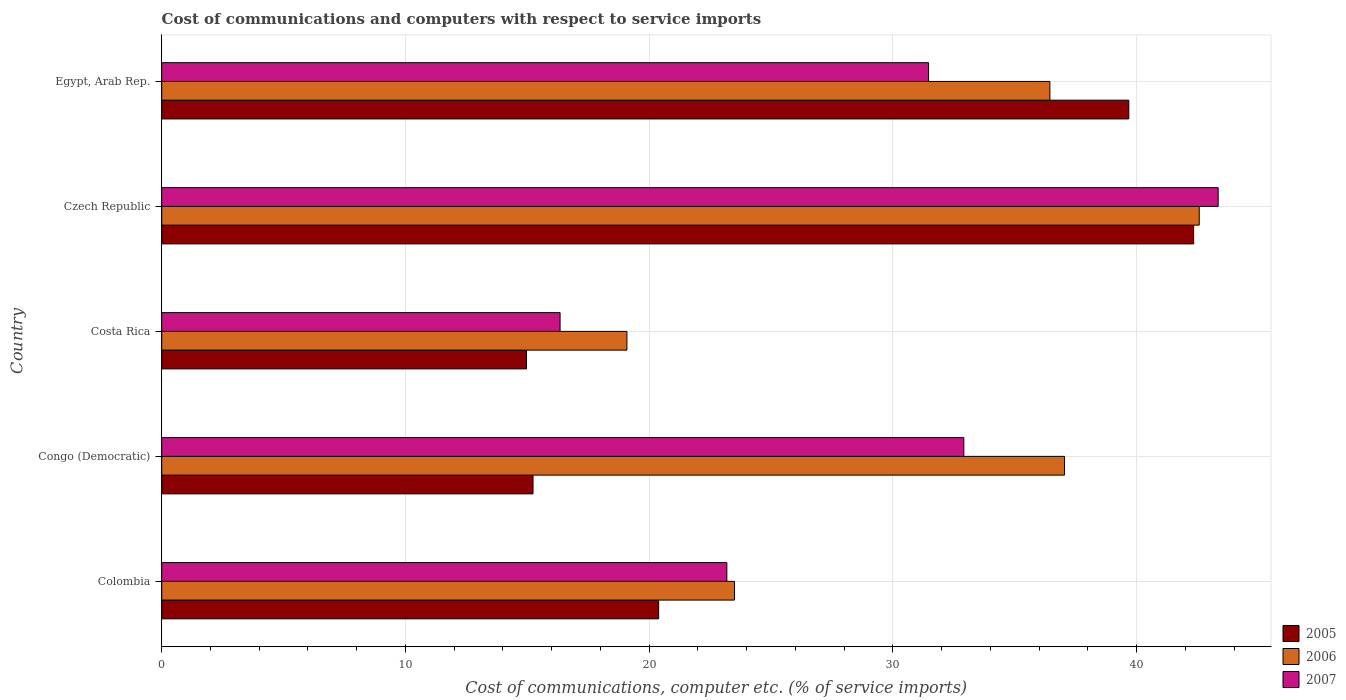How many different coloured bars are there?
Keep it short and to the point. 3. How many groups of bars are there?
Give a very brief answer. 5. How many bars are there on the 5th tick from the top?
Give a very brief answer. 3. What is the label of the 3rd group of bars from the top?
Your answer should be very brief. Costa Rica. What is the cost of communications and computers in 2005 in Congo (Democratic)?
Offer a terse response. 15.23. Across all countries, what is the maximum cost of communications and computers in 2007?
Keep it short and to the point. 43.34. Across all countries, what is the minimum cost of communications and computers in 2006?
Make the answer very short. 19.09. In which country was the cost of communications and computers in 2007 maximum?
Your answer should be compact. Czech Republic. What is the total cost of communications and computers in 2007 in the graph?
Ensure brevity in your answer.  147.24. What is the difference between the cost of communications and computers in 2006 in Costa Rica and that in Czech Republic?
Keep it short and to the point. -23.48. What is the difference between the cost of communications and computers in 2006 in Czech Republic and the cost of communications and computers in 2007 in Colombia?
Your answer should be very brief. 19.38. What is the average cost of communications and computers in 2005 per country?
Provide a succinct answer. 26.52. What is the difference between the cost of communications and computers in 2005 and cost of communications and computers in 2006 in Czech Republic?
Your answer should be compact. -0.23. In how many countries, is the cost of communications and computers in 2005 greater than 34 %?
Your response must be concise. 2. What is the ratio of the cost of communications and computers in 2006 in Costa Rica to that in Egypt, Arab Rep.?
Give a very brief answer. 0.52. Is the cost of communications and computers in 2006 in Congo (Democratic) less than that in Egypt, Arab Rep.?
Ensure brevity in your answer.  No. Is the difference between the cost of communications and computers in 2005 in Czech Republic and Egypt, Arab Rep. greater than the difference between the cost of communications and computers in 2006 in Czech Republic and Egypt, Arab Rep.?
Keep it short and to the point. No. What is the difference between the highest and the second highest cost of communications and computers in 2006?
Your response must be concise. 5.53. What is the difference between the highest and the lowest cost of communications and computers in 2006?
Keep it short and to the point. 23.48. In how many countries, is the cost of communications and computers in 2007 greater than the average cost of communications and computers in 2007 taken over all countries?
Your answer should be compact. 3. Is the sum of the cost of communications and computers in 2005 in Czech Republic and Egypt, Arab Rep. greater than the maximum cost of communications and computers in 2007 across all countries?
Your answer should be compact. Yes. How many bars are there?
Provide a short and direct response. 15. Are all the bars in the graph horizontal?
Make the answer very short. Yes. Does the graph contain any zero values?
Offer a very short reply. No. Where does the legend appear in the graph?
Make the answer very short. Bottom right. What is the title of the graph?
Offer a terse response. Cost of communications and computers with respect to service imports. What is the label or title of the X-axis?
Offer a terse response. Cost of communications, computer etc. (% of service imports). What is the Cost of communications, computer etc. (% of service imports) of 2005 in Colombia?
Your answer should be very brief. 20.39. What is the Cost of communications, computer etc. (% of service imports) in 2006 in Colombia?
Keep it short and to the point. 23.5. What is the Cost of communications, computer etc. (% of service imports) in 2007 in Colombia?
Provide a succinct answer. 23.18. What is the Cost of communications, computer etc. (% of service imports) in 2005 in Congo (Democratic)?
Ensure brevity in your answer.  15.23. What is the Cost of communications, computer etc. (% of service imports) in 2006 in Congo (Democratic)?
Offer a very short reply. 37.04. What is the Cost of communications, computer etc. (% of service imports) of 2007 in Congo (Democratic)?
Offer a very short reply. 32.91. What is the Cost of communications, computer etc. (% of service imports) of 2005 in Costa Rica?
Your answer should be very brief. 14.97. What is the Cost of communications, computer etc. (% of service imports) of 2006 in Costa Rica?
Your answer should be very brief. 19.09. What is the Cost of communications, computer etc. (% of service imports) of 2007 in Costa Rica?
Your response must be concise. 16.34. What is the Cost of communications, computer etc. (% of service imports) of 2005 in Czech Republic?
Provide a short and direct response. 42.33. What is the Cost of communications, computer etc. (% of service imports) in 2006 in Czech Republic?
Ensure brevity in your answer.  42.56. What is the Cost of communications, computer etc. (% of service imports) in 2007 in Czech Republic?
Your answer should be very brief. 43.34. What is the Cost of communications, computer etc. (% of service imports) in 2005 in Egypt, Arab Rep.?
Provide a succinct answer. 39.68. What is the Cost of communications, computer etc. (% of service imports) in 2006 in Egypt, Arab Rep.?
Provide a short and direct response. 36.44. What is the Cost of communications, computer etc. (% of service imports) in 2007 in Egypt, Arab Rep.?
Make the answer very short. 31.46. Across all countries, what is the maximum Cost of communications, computer etc. (% of service imports) of 2005?
Your answer should be very brief. 42.33. Across all countries, what is the maximum Cost of communications, computer etc. (% of service imports) of 2006?
Your response must be concise. 42.56. Across all countries, what is the maximum Cost of communications, computer etc. (% of service imports) of 2007?
Offer a terse response. 43.34. Across all countries, what is the minimum Cost of communications, computer etc. (% of service imports) in 2005?
Your answer should be very brief. 14.97. Across all countries, what is the minimum Cost of communications, computer etc. (% of service imports) in 2006?
Give a very brief answer. 19.09. Across all countries, what is the minimum Cost of communications, computer etc. (% of service imports) in 2007?
Your answer should be very brief. 16.34. What is the total Cost of communications, computer etc. (% of service imports) of 2005 in the graph?
Give a very brief answer. 132.6. What is the total Cost of communications, computer etc. (% of service imports) of 2006 in the graph?
Keep it short and to the point. 158.63. What is the total Cost of communications, computer etc. (% of service imports) in 2007 in the graph?
Offer a terse response. 147.24. What is the difference between the Cost of communications, computer etc. (% of service imports) of 2005 in Colombia and that in Congo (Democratic)?
Your answer should be compact. 5.15. What is the difference between the Cost of communications, computer etc. (% of service imports) of 2006 in Colombia and that in Congo (Democratic)?
Make the answer very short. -13.54. What is the difference between the Cost of communications, computer etc. (% of service imports) of 2007 in Colombia and that in Congo (Democratic)?
Provide a short and direct response. -9.72. What is the difference between the Cost of communications, computer etc. (% of service imports) of 2005 in Colombia and that in Costa Rica?
Offer a terse response. 5.42. What is the difference between the Cost of communications, computer etc. (% of service imports) in 2006 in Colombia and that in Costa Rica?
Ensure brevity in your answer.  4.41. What is the difference between the Cost of communications, computer etc. (% of service imports) in 2007 in Colombia and that in Costa Rica?
Your answer should be very brief. 6.84. What is the difference between the Cost of communications, computer etc. (% of service imports) in 2005 in Colombia and that in Czech Republic?
Offer a terse response. -21.95. What is the difference between the Cost of communications, computer etc. (% of service imports) in 2006 in Colombia and that in Czech Republic?
Provide a short and direct response. -19.06. What is the difference between the Cost of communications, computer etc. (% of service imports) in 2007 in Colombia and that in Czech Republic?
Keep it short and to the point. -20.16. What is the difference between the Cost of communications, computer etc. (% of service imports) in 2005 in Colombia and that in Egypt, Arab Rep.?
Your response must be concise. -19.29. What is the difference between the Cost of communications, computer etc. (% of service imports) of 2006 in Colombia and that in Egypt, Arab Rep.?
Offer a very short reply. -12.94. What is the difference between the Cost of communications, computer etc. (% of service imports) of 2007 in Colombia and that in Egypt, Arab Rep.?
Give a very brief answer. -8.28. What is the difference between the Cost of communications, computer etc. (% of service imports) in 2005 in Congo (Democratic) and that in Costa Rica?
Provide a short and direct response. 0.27. What is the difference between the Cost of communications, computer etc. (% of service imports) of 2006 in Congo (Democratic) and that in Costa Rica?
Provide a short and direct response. 17.95. What is the difference between the Cost of communications, computer etc. (% of service imports) of 2007 in Congo (Democratic) and that in Costa Rica?
Ensure brevity in your answer.  16.56. What is the difference between the Cost of communications, computer etc. (% of service imports) in 2005 in Congo (Democratic) and that in Czech Republic?
Give a very brief answer. -27.1. What is the difference between the Cost of communications, computer etc. (% of service imports) in 2006 in Congo (Democratic) and that in Czech Republic?
Give a very brief answer. -5.53. What is the difference between the Cost of communications, computer etc. (% of service imports) of 2007 in Congo (Democratic) and that in Czech Republic?
Give a very brief answer. -10.43. What is the difference between the Cost of communications, computer etc. (% of service imports) of 2005 in Congo (Democratic) and that in Egypt, Arab Rep.?
Provide a short and direct response. -24.44. What is the difference between the Cost of communications, computer etc. (% of service imports) in 2006 in Congo (Democratic) and that in Egypt, Arab Rep.?
Provide a succinct answer. 0.6. What is the difference between the Cost of communications, computer etc. (% of service imports) of 2007 in Congo (Democratic) and that in Egypt, Arab Rep.?
Give a very brief answer. 1.45. What is the difference between the Cost of communications, computer etc. (% of service imports) of 2005 in Costa Rica and that in Czech Republic?
Provide a succinct answer. -27.37. What is the difference between the Cost of communications, computer etc. (% of service imports) of 2006 in Costa Rica and that in Czech Republic?
Offer a terse response. -23.48. What is the difference between the Cost of communications, computer etc. (% of service imports) in 2007 in Costa Rica and that in Czech Republic?
Provide a succinct answer. -27. What is the difference between the Cost of communications, computer etc. (% of service imports) in 2005 in Costa Rica and that in Egypt, Arab Rep.?
Offer a very short reply. -24.71. What is the difference between the Cost of communications, computer etc. (% of service imports) of 2006 in Costa Rica and that in Egypt, Arab Rep.?
Your answer should be very brief. -17.35. What is the difference between the Cost of communications, computer etc. (% of service imports) of 2007 in Costa Rica and that in Egypt, Arab Rep.?
Offer a terse response. -15.12. What is the difference between the Cost of communications, computer etc. (% of service imports) of 2005 in Czech Republic and that in Egypt, Arab Rep.?
Make the answer very short. 2.66. What is the difference between the Cost of communications, computer etc. (% of service imports) of 2006 in Czech Republic and that in Egypt, Arab Rep.?
Offer a very short reply. 6.13. What is the difference between the Cost of communications, computer etc. (% of service imports) in 2007 in Czech Republic and that in Egypt, Arab Rep.?
Make the answer very short. 11.88. What is the difference between the Cost of communications, computer etc. (% of service imports) of 2005 in Colombia and the Cost of communications, computer etc. (% of service imports) of 2006 in Congo (Democratic)?
Offer a very short reply. -16.65. What is the difference between the Cost of communications, computer etc. (% of service imports) in 2005 in Colombia and the Cost of communications, computer etc. (% of service imports) in 2007 in Congo (Democratic)?
Offer a very short reply. -12.52. What is the difference between the Cost of communications, computer etc. (% of service imports) in 2006 in Colombia and the Cost of communications, computer etc. (% of service imports) in 2007 in Congo (Democratic)?
Give a very brief answer. -9.41. What is the difference between the Cost of communications, computer etc. (% of service imports) in 2005 in Colombia and the Cost of communications, computer etc. (% of service imports) in 2006 in Costa Rica?
Ensure brevity in your answer.  1.3. What is the difference between the Cost of communications, computer etc. (% of service imports) in 2005 in Colombia and the Cost of communications, computer etc. (% of service imports) in 2007 in Costa Rica?
Keep it short and to the point. 4.04. What is the difference between the Cost of communications, computer etc. (% of service imports) in 2006 in Colombia and the Cost of communications, computer etc. (% of service imports) in 2007 in Costa Rica?
Provide a short and direct response. 7.16. What is the difference between the Cost of communications, computer etc. (% of service imports) in 2005 in Colombia and the Cost of communications, computer etc. (% of service imports) in 2006 in Czech Republic?
Offer a very short reply. -22.18. What is the difference between the Cost of communications, computer etc. (% of service imports) of 2005 in Colombia and the Cost of communications, computer etc. (% of service imports) of 2007 in Czech Republic?
Your answer should be compact. -22.95. What is the difference between the Cost of communications, computer etc. (% of service imports) of 2006 in Colombia and the Cost of communications, computer etc. (% of service imports) of 2007 in Czech Republic?
Your answer should be very brief. -19.84. What is the difference between the Cost of communications, computer etc. (% of service imports) in 2005 in Colombia and the Cost of communications, computer etc. (% of service imports) in 2006 in Egypt, Arab Rep.?
Give a very brief answer. -16.05. What is the difference between the Cost of communications, computer etc. (% of service imports) in 2005 in Colombia and the Cost of communications, computer etc. (% of service imports) in 2007 in Egypt, Arab Rep.?
Offer a very short reply. -11.07. What is the difference between the Cost of communications, computer etc. (% of service imports) in 2006 in Colombia and the Cost of communications, computer etc. (% of service imports) in 2007 in Egypt, Arab Rep.?
Keep it short and to the point. -7.96. What is the difference between the Cost of communications, computer etc. (% of service imports) in 2005 in Congo (Democratic) and the Cost of communications, computer etc. (% of service imports) in 2006 in Costa Rica?
Provide a succinct answer. -3.85. What is the difference between the Cost of communications, computer etc. (% of service imports) in 2005 in Congo (Democratic) and the Cost of communications, computer etc. (% of service imports) in 2007 in Costa Rica?
Offer a terse response. -1.11. What is the difference between the Cost of communications, computer etc. (% of service imports) of 2006 in Congo (Democratic) and the Cost of communications, computer etc. (% of service imports) of 2007 in Costa Rica?
Make the answer very short. 20.7. What is the difference between the Cost of communications, computer etc. (% of service imports) in 2005 in Congo (Democratic) and the Cost of communications, computer etc. (% of service imports) in 2006 in Czech Republic?
Your answer should be compact. -27.33. What is the difference between the Cost of communications, computer etc. (% of service imports) in 2005 in Congo (Democratic) and the Cost of communications, computer etc. (% of service imports) in 2007 in Czech Republic?
Keep it short and to the point. -28.11. What is the difference between the Cost of communications, computer etc. (% of service imports) in 2006 in Congo (Democratic) and the Cost of communications, computer etc. (% of service imports) in 2007 in Czech Republic?
Offer a very short reply. -6.3. What is the difference between the Cost of communications, computer etc. (% of service imports) in 2005 in Congo (Democratic) and the Cost of communications, computer etc. (% of service imports) in 2006 in Egypt, Arab Rep.?
Provide a succinct answer. -21.2. What is the difference between the Cost of communications, computer etc. (% of service imports) of 2005 in Congo (Democratic) and the Cost of communications, computer etc. (% of service imports) of 2007 in Egypt, Arab Rep.?
Keep it short and to the point. -16.23. What is the difference between the Cost of communications, computer etc. (% of service imports) in 2006 in Congo (Democratic) and the Cost of communications, computer etc. (% of service imports) in 2007 in Egypt, Arab Rep.?
Offer a very short reply. 5.58. What is the difference between the Cost of communications, computer etc. (% of service imports) in 2005 in Costa Rica and the Cost of communications, computer etc. (% of service imports) in 2006 in Czech Republic?
Your response must be concise. -27.6. What is the difference between the Cost of communications, computer etc. (% of service imports) of 2005 in Costa Rica and the Cost of communications, computer etc. (% of service imports) of 2007 in Czech Republic?
Ensure brevity in your answer.  -28.38. What is the difference between the Cost of communications, computer etc. (% of service imports) of 2006 in Costa Rica and the Cost of communications, computer etc. (% of service imports) of 2007 in Czech Republic?
Keep it short and to the point. -24.26. What is the difference between the Cost of communications, computer etc. (% of service imports) in 2005 in Costa Rica and the Cost of communications, computer etc. (% of service imports) in 2006 in Egypt, Arab Rep.?
Offer a terse response. -21.47. What is the difference between the Cost of communications, computer etc. (% of service imports) of 2005 in Costa Rica and the Cost of communications, computer etc. (% of service imports) of 2007 in Egypt, Arab Rep.?
Your response must be concise. -16.49. What is the difference between the Cost of communications, computer etc. (% of service imports) of 2006 in Costa Rica and the Cost of communications, computer etc. (% of service imports) of 2007 in Egypt, Arab Rep.?
Keep it short and to the point. -12.37. What is the difference between the Cost of communications, computer etc. (% of service imports) of 2005 in Czech Republic and the Cost of communications, computer etc. (% of service imports) of 2006 in Egypt, Arab Rep.?
Offer a very short reply. 5.9. What is the difference between the Cost of communications, computer etc. (% of service imports) of 2005 in Czech Republic and the Cost of communications, computer etc. (% of service imports) of 2007 in Egypt, Arab Rep.?
Keep it short and to the point. 10.88. What is the difference between the Cost of communications, computer etc. (% of service imports) of 2006 in Czech Republic and the Cost of communications, computer etc. (% of service imports) of 2007 in Egypt, Arab Rep.?
Your answer should be compact. 11.1. What is the average Cost of communications, computer etc. (% of service imports) in 2005 per country?
Ensure brevity in your answer.  26.52. What is the average Cost of communications, computer etc. (% of service imports) of 2006 per country?
Your response must be concise. 31.73. What is the average Cost of communications, computer etc. (% of service imports) of 2007 per country?
Your answer should be very brief. 29.45. What is the difference between the Cost of communications, computer etc. (% of service imports) of 2005 and Cost of communications, computer etc. (% of service imports) of 2006 in Colombia?
Give a very brief answer. -3.11. What is the difference between the Cost of communications, computer etc. (% of service imports) of 2005 and Cost of communications, computer etc. (% of service imports) of 2007 in Colombia?
Ensure brevity in your answer.  -2.8. What is the difference between the Cost of communications, computer etc. (% of service imports) in 2006 and Cost of communications, computer etc. (% of service imports) in 2007 in Colombia?
Your answer should be very brief. 0.32. What is the difference between the Cost of communications, computer etc. (% of service imports) of 2005 and Cost of communications, computer etc. (% of service imports) of 2006 in Congo (Democratic)?
Provide a short and direct response. -21.81. What is the difference between the Cost of communications, computer etc. (% of service imports) of 2005 and Cost of communications, computer etc. (% of service imports) of 2007 in Congo (Democratic)?
Give a very brief answer. -17.67. What is the difference between the Cost of communications, computer etc. (% of service imports) in 2006 and Cost of communications, computer etc. (% of service imports) in 2007 in Congo (Democratic)?
Give a very brief answer. 4.13. What is the difference between the Cost of communications, computer etc. (% of service imports) in 2005 and Cost of communications, computer etc. (% of service imports) in 2006 in Costa Rica?
Ensure brevity in your answer.  -4.12. What is the difference between the Cost of communications, computer etc. (% of service imports) of 2005 and Cost of communications, computer etc. (% of service imports) of 2007 in Costa Rica?
Your answer should be very brief. -1.38. What is the difference between the Cost of communications, computer etc. (% of service imports) of 2006 and Cost of communications, computer etc. (% of service imports) of 2007 in Costa Rica?
Offer a terse response. 2.74. What is the difference between the Cost of communications, computer etc. (% of service imports) of 2005 and Cost of communications, computer etc. (% of service imports) of 2006 in Czech Republic?
Provide a short and direct response. -0.23. What is the difference between the Cost of communications, computer etc. (% of service imports) in 2005 and Cost of communications, computer etc. (% of service imports) in 2007 in Czech Republic?
Give a very brief answer. -1.01. What is the difference between the Cost of communications, computer etc. (% of service imports) of 2006 and Cost of communications, computer etc. (% of service imports) of 2007 in Czech Republic?
Give a very brief answer. -0.78. What is the difference between the Cost of communications, computer etc. (% of service imports) in 2005 and Cost of communications, computer etc. (% of service imports) in 2006 in Egypt, Arab Rep.?
Your response must be concise. 3.24. What is the difference between the Cost of communications, computer etc. (% of service imports) in 2005 and Cost of communications, computer etc. (% of service imports) in 2007 in Egypt, Arab Rep.?
Provide a short and direct response. 8.22. What is the difference between the Cost of communications, computer etc. (% of service imports) in 2006 and Cost of communications, computer etc. (% of service imports) in 2007 in Egypt, Arab Rep.?
Give a very brief answer. 4.98. What is the ratio of the Cost of communications, computer etc. (% of service imports) of 2005 in Colombia to that in Congo (Democratic)?
Keep it short and to the point. 1.34. What is the ratio of the Cost of communications, computer etc. (% of service imports) in 2006 in Colombia to that in Congo (Democratic)?
Give a very brief answer. 0.63. What is the ratio of the Cost of communications, computer etc. (% of service imports) of 2007 in Colombia to that in Congo (Democratic)?
Offer a terse response. 0.7. What is the ratio of the Cost of communications, computer etc. (% of service imports) of 2005 in Colombia to that in Costa Rica?
Make the answer very short. 1.36. What is the ratio of the Cost of communications, computer etc. (% of service imports) in 2006 in Colombia to that in Costa Rica?
Keep it short and to the point. 1.23. What is the ratio of the Cost of communications, computer etc. (% of service imports) of 2007 in Colombia to that in Costa Rica?
Your response must be concise. 1.42. What is the ratio of the Cost of communications, computer etc. (% of service imports) of 2005 in Colombia to that in Czech Republic?
Ensure brevity in your answer.  0.48. What is the ratio of the Cost of communications, computer etc. (% of service imports) of 2006 in Colombia to that in Czech Republic?
Provide a short and direct response. 0.55. What is the ratio of the Cost of communications, computer etc. (% of service imports) of 2007 in Colombia to that in Czech Republic?
Your response must be concise. 0.53. What is the ratio of the Cost of communications, computer etc. (% of service imports) in 2005 in Colombia to that in Egypt, Arab Rep.?
Offer a very short reply. 0.51. What is the ratio of the Cost of communications, computer etc. (% of service imports) in 2006 in Colombia to that in Egypt, Arab Rep.?
Your answer should be compact. 0.64. What is the ratio of the Cost of communications, computer etc. (% of service imports) in 2007 in Colombia to that in Egypt, Arab Rep.?
Make the answer very short. 0.74. What is the ratio of the Cost of communications, computer etc. (% of service imports) in 2005 in Congo (Democratic) to that in Costa Rica?
Provide a succinct answer. 1.02. What is the ratio of the Cost of communications, computer etc. (% of service imports) of 2006 in Congo (Democratic) to that in Costa Rica?
Give a very brief answer. 1.94. What is the ratio of the Cost of communications, computer etc. (% of service imports) in 2007 in Congo (Democratic) to that in Costa Rica?
Keep it short and to the point. 2.01. What is the ratio of the Cost of communications, computer etc. (% of service imports) of 2005 in Congo (Democratic) to that in Czech Republic?
Provide a short and direct response. 0.36. What is the ratio of the Cost of communications, computer etc. (% of service imports) in 2006 in Congo (Democratic) to that in Czech Republic?
Your response must be concise. 0.87. What is the ratio of the Cost of communications, computer etc. (% of service imports) in 2007 in Congo (Democratic) to that in Czech Republic?
Offer a terse response. 0.76. What is the ratio of the Cost of communications, computer etc. (% of service imports) of 2005 in Congo (Democratic) to that in Egypt, Arab Rep.?
Keep it short and to the point. 0.38. What is the ratio of the Cost of communications, computer etc. (% of service imports) in 2006 in Congo (Democratic) to that in Egypt, Arab Rep.?
Provide a short and direct response. 1.02. What is the ratio of the Cost of communications, computer etc. (% of service imports) in 2007 in Congo (Democratic) to that in Egypt, Arab Rep.?
Your response must be concise. 1.05. What is the ratio of the Cost of communications, computer etc. (% of service imports) in 2005 in Costa Rica to that in Czech Republic?
Provide a short and direct response. 0.35. What is the ratio of the Cost of communications, computer etc. (% of service imports) of 2006 in Costa Rica to that in Czech Republic?
Offer a terse response. 0.45. What is the ratio of the Cost of communications, computer etc. (% of service imports) of 2007 in Costa Rica to that in Czech Republic?
Your answer should be compact. 0.38. What is the ratio of the Cost of communications, computer etc. (% of service imports) of 2005 in Costa Rica to that in Egypt, Arab Rep.?
Your response must be concise. 0.38. What is the ratio of the Cost of communications, computer etc. (% of service imports) in 2006 in Costa Rica to that in Egypt, Arab Rep.?
Your response must be concise. 0.52. What is the ratio of the Cost of communications, computer etc. (% of service imports) of 2007 in Costa Rica to that in Egypt, Arab Rep.?
Offer a very short reply. 0.52. What is the ratio of the Cost of communications, computer etc. (% of service imports) in 2005 in Czech Republic to that in Egypt, Arab Rep.?
Your answer should be very brief. 1.07. What is the ratio of the Cost of communications, computer etc. (% of service imports) of 2006 in Czech Republic to that in Egypt, Arab Rep.?
Give a very brief answer. 1.17. What is the ratio of the Cost of communications, computer etc. (% of service imports) in 2007 in Czech Republic to that in Egypt, Arab Rep.?
Your answer should be very brief. 1.38. What is the difference between the highest and the second highest Cost of communications, computer etc. (% of service imports) of 2005?
Offer a terse response. 2.66. What is the difference between the highest and the second highest Cost of communications, computer etc. (% of service imports) in 2006?
Make the answer very short. 5.53. What is the difference between the highest and the second highest Cost of communications, computer etc. (% of service imports) in 2007?
Give a very brief answer. 10.43. What is the difference between the highest and the lowest Cost of communications, computer etc. (% of service imports) in 2005?
Offer a very short reply. 27.37. What is the difference between the highest and the lowest Cost of communications, computer etc. (% of service imports) in 2006?
Your answer should be compact. 23.48. What is the difference between the highest and the lowest Cost of communications, computer etc. (% of service imports) of 2007?
Give a very brief answer. 27. 